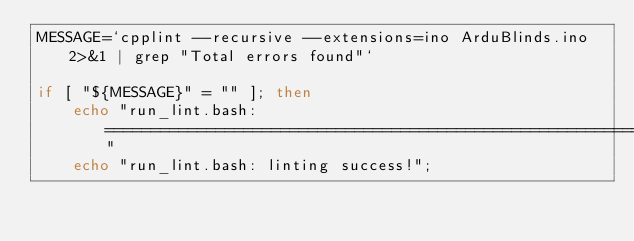Convert code to text. <code><loc_0><loc_0><loc_500><loc_500><_Bash_>MESSAGE=`cpplint --recursive --extensions=ino ArduBlinds.ino 2>&1 | grep "Total errors found"`

if [ "${MESSAGE}" = "" ]; then
    echo "run_lint.bash: ======================================================================="
    echo "run_lint.bash: linting success!";</code> 